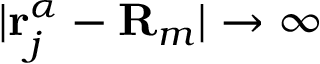Convert formula to latex. <formula><loc_0><loc_0><loc_500><loc_500>| r _ { j } ^ { \alpha } - R _ { m } | \rightarrow \infty</formula> 